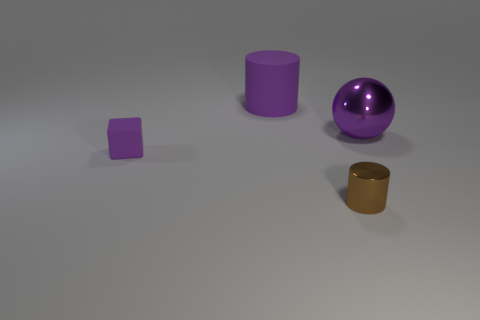Add 4 matte things. How many objects exist? 8 Subtract all brown cylinders. How many cylinders are left? 1 Subtract 2 cylinders. How many cylinders are left? 0 Subtract all spheres. How many objects are left? 3 Add 2 small cubes. How many small cubes are left? 3 Add 1 tiny blue rubber spheres. How many tiny blue rubber spheres exist? 1 Subtract 0 green cylinders. How many objects are left? 4 Subtract all gray cylinders. Subtract all cyan spheres. How many cylinders are left? 2 Subtract all big things. Subtract all large objects. How many objects are left? 0 